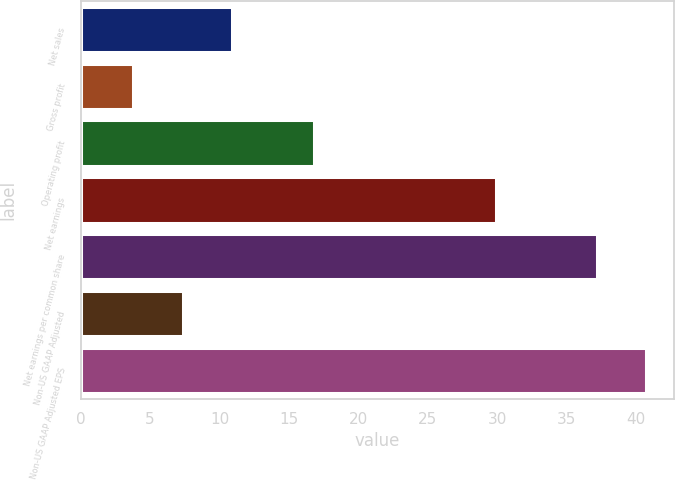Convert chart to OTSL. <chart><loc_0><loc_0><loc_500><loc_500><bar_chart><fcel>Net sales<fcel>Gross profit<fcel>Operating profit<fcel>Net earnings<fcel>Net earnings per common share<fcel>Non-US GAAP Adjusted<fcel>Non-US GAAP Adjusted EPS<nl><fcel>10.88<fcel>3.8<fcel>16.8<fcel>29.9<fcel>37.14<fcel>7.34<fcel>40.68<nl></chart> 